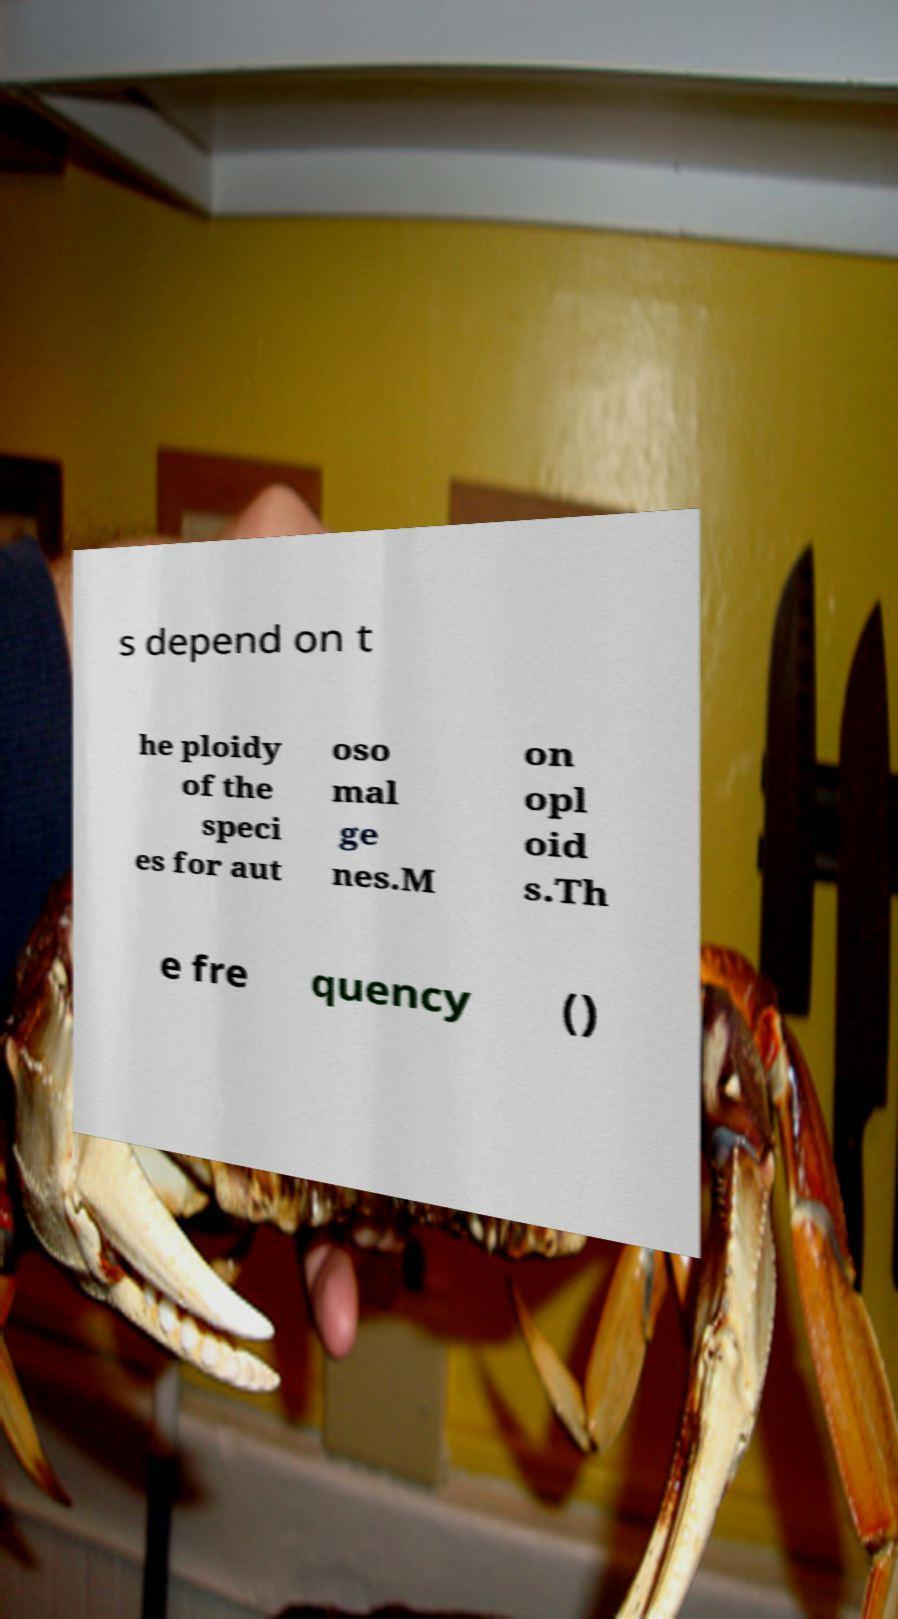Please read and relay the text visible in this image. What does it say? s depend on t he ploidy of the speci es for aut oso mal ge nes.M on opl oid s.Th e fre quency () 